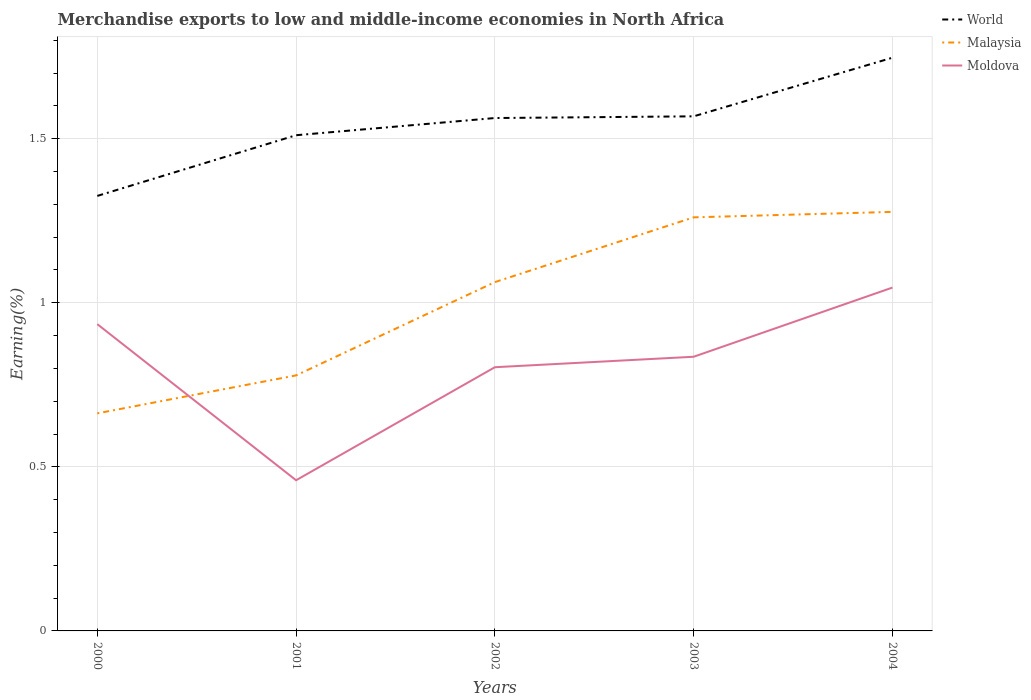Does the line corresponding to Moldova intersect with the line corresponding to Malaysia?
Provide a short and direct response. Yes. Is the number of lines equal to the number of legend labels?
Your response must be concise. Yes. Across all years, what is the maximum percentage of amount earned from merchandise exports in World?
Your answer should be compact. 1.33. What is the total percentage of amount earned from merchandise exports in World in the graph?
Offer a terse response. -0.18. What is the difference between the highest and the second highest percentage of amount earned from merchandise exports in Moldova?
Give a very brief answer. 0.59. Is the percentage of amount earned from merchandise exports in Malaysia strictly greater than the percentage of amount earned from merchandise exports in World over the years?
Make the answer very short. Yes. What is the difference between two consecutive major ticks on the Y-axis?
Make the answer very short. 0.5. How many legend labels are there?
Offer a very short reply. 3. What is the title of the graph?
Give a very brief answer. Merchandise exports to low and middle-income economies in North Africa. Does "Samoa" appear as one of the legend labels in the graph?
Your answer should be compact. No. What is the label or title of the X-axis?
Your answer should be very brief. Years. What is the label or title of the Y-axis?
Offer a very short reply. Earning(%). What is the Earning(%) in World in 2000?
Give a very brief answer. 1.33. What is the Earning(%) in Malaysia in 2000?
Give a very brief answer. 0.66. What is the Earning(%) of Moldova in 2000?
Your answer should be compact. 0.93. What is the Earning(%) in World in 2001?
Provide a short and direct response. 1.51. What is the Earning(%) in Malaysia in 2001?
Offer a very short reply. 0.78. What is the Earning(%) of Moldova in 2001?
Offer a terse response. 0.46. What is the Earning(%) of World in 2002?
Give a very brief answer. 1.56. What is the Earning(%) in Malaysia in 2002?
Ensure brevity in your answer.  1.06. What is the Earning(%) in Moldova in 2002?
Provide a succinct answer. 0.8. What is the Earning(%) of World in 2003?
Offer a very short reply. 1.57. What is the Earning(%) in Malaysia in 2003?
Offer a very short reply. 1.26. What is the Earning(%) of Moldova in 2003?
Provide a short and direct response. 0.84. What is the Earning(%) in World in 2004?
Your answer should be compact. 1.75. What is the Earning(%) of Malaysia in 2004?
Your response must be concise. 1.28. What is the Earning(%) of Moldova in 2004?
Keep it short and to the point. 1.05. Across all years, what is the maximum Earning(%) of World?
Ensure brevity in your answer.  1.75. Across all years, what is the maximum Earning(%) in Malaysia?
Offer a very short reply. 1.28. Across all years, what is the maximum Earning(%) in Moldova?
Provide a short and direct response. 1.05. Across all years, what is the minimum Earning(%) in World?
Your answer should be compact. 1.33. Across all years, what is the minimum Earning(%) of Malaysia?
Ensure brevity in your answer.  0.66. Across all years, what is the minimum Earning(%) in Moldova?
Your answer should be very brief. 0.46. What is the total Earning(%) of World in the graph?
Provide a succinct answer. 7.71. What is the total Earning(%) of Malaysia in the graph?
Offer a very short reply. 5.04. What is the total Earning(%) of Moldova in the graph?
Offer a very short reply. 4.08. What is the difference between the Earning(%) of World in 2000 and that in 2001?
Offer a terse response. -0.18. What is the difference between the Earning(%) of Malaysia in 2000 and that in 2001?
Your answer should be very brief. -0.12. What is the difference between the Earning(%) in Moldova in 2000 and that in 2001?
Keep it short and to the point. 0.48. What is the difference between the Earning(%) of World in 2000 and that in 2002?
Ensure brevity in your answer.  -0.24. What is the difference between the Earning(%) of Malaysia in 2000 and that in 2002?
Keep it short and to the point. -0.4. What is the difference between the Earning(%) of Moldova in 2000 and that in 2002?
Provide a succinct answer. 0.13. What is the difference between the Earning(%) of World in 2000 and that in 2003?
Offer a very short reply. -0.24. What is the difference between the Earning(%) in Malaysia in 2000 and that in 2003?
Keep it short and to the point. -0.6. What is the difference between the Earning(%) in Moldova in 2000 and that in 2003?
Provide a short and direct response. 0.1. What is the difference between the Earning(%) of World in 2000 and that in 2004?
Your response must be concise. -0.42. What is the difference between the Earning(%) in Malaysia in 2000 and that in 2004?
Your answer should be very brief. -0.61. What is the difference between the Earning(%) of Moldova in 2000 and that in 2004?
Your answer should be compact. -0.11. What is the difference between the Earning(%) in World in 2001 and that in 2002?
Keep it short and to the point. -0.05. What is the difference between the Earning(%) of Malaysia in 2001 and that in 2002?
Your answer should be compact. -0.28. What is the difference between the Earning(%) in Moldova in 2001 and that in 2002?
Offer a terse response. -0.34. What is the difference between the Earning(%) of World in 2001 and that in 2003?
Your answer should be compact. -0.06. What is the difference between the Earning(%) in Malaysia in 2001 and that in 2003?
Give a very brief answer. -0.48. What is the difference between the Earning(%) of Moldova in 2001 and that in 2003?
Provide a succinct answer. -0.38. What is the difference between the Earning(%) of World in 2001 and that in 2004?
Offer a terse response. -0.24. What is the difference between the Earning(%) of Malaysia in 2001 and that in 2004?
Your answer should be very brief. -0.5. What is the difference between the Earning(%) of Moldova in 2001 and that in 2004?
Give a very brief answer. -0.59. What is the difference between the Earning(%) in World in 2002 and that in 2003?
Provide a succinct answer. -0.01. What is the difference between the Earning(%) of Malaysia in 2002 and that in 2003?
Your response must be concise. -0.2. What is the difference between the Earning(%) in Moldova in 2002 and that in 2003?
Offer a terse response. -0.03. What is the difference between the Earning(%) in World in 2002 and that in 2004?
Ensure brevity in your answer.  -0.18. What is the difference between the Earning(%) in Malaysia in 2002 and that in 2004?
Give a very brief answer. -0.21. What is the difference between the Earning(%) in Moldova in 2002 and that in 2004?
Offer a very short reply. -0.24. What is the difference between the Earning(%) in World in 2003 and that in 2004?
Give a very brief answer. -0.18. What is the difference between the Earning(%) of Malaysia in 2003 and that in 2004?
Give a very brief answer. -0.02. What is the difference between the Earning(%) of Moldova in 2003 and that in 2004?
Offer a terse response. -0.21. What is the difference between the Earning(%) of World in 2000 and the Earning(%) of Malaysia in 2001?
Your response must be concise. 0.55. What is the difference between the Earning(%) in World in 2000 and the Earning(%) in Moldova in 2001?
Ensure brevity in your answer.  0.87. What is the difference between the Earning(%) in Malaysia in 2000 and the Earning(%) in Moldova in 2001?
Provide a short and direct response. 0.2. What is the difference between the Earning(%) in World in 2000 and the Earning(%) in Malaysia in 2002?
Your response must be concise. 0.26. What is the difference between the Earning(%) of World in 2000 and the Earning(%) of Moldova in 2002?
Keep it short and to the point. 0.52. What is the difference between the Earning(%) in Malaysia in 2000 and the Earning(%) in Moldova in 2002?
Your response must be concise. -0.14. What is the difference between the Earning(%) of World in 2000 and the Earning(%) of Malaysia in 2003?
Offer a very short reply. 0.07. What is the difference between the Earning(%) of World in 2000 and the Earning(%) of Moldova in 2003?
Provide a short and direct response. 0.49. What is the difference between the Earning(%) in Malaysia in 2000 and the Earning(%) in Moldova in 2003?
Provide a succinct answer. -0.17. What is the difference between the Earning(%) of World in 2000 and the Earning(%) of Malaysia in 2004?
Ensure brevity in your answer.  0.05. What is the difference between the Earning(%) of World in 2000 and the Earning(%) of Moldova in 2004?
Provide a short and direct response. 0.28. What is the difference between the Earning(%) in Malaysia in 2000 and the Earning(%) in Moldova in 2004?
Make the answer very short. -0.38. What is the difference between the Earning(%) of World in 2001 and the Earning(%) of Malaysia in 2002?
Keep it short and to the point. 0.45. What is the difference between the Earning(%) in World in 2001 and the Earning(%) in Moldova in 2002?
Make the answer very short. 0.71. What is the difference between the Earning(%) in Malaysia in 2001 and the Earning(%) in Moldova in 2002?
Provide a short and direct response. -0.02. What is the difference between the Earning(%) in World in 2001 and the Earning(%) in Malaysia in 2003?
Your answer should be compact. 0.25. What is the difference between the Earning(%) of World in 2001 and the Earning(%) of Moldova in 2003?
Give a very brief answer. 0.68. What is the difference between the Earning(%) of Malaysia in 2001 and the Earning(%) of Moldova in 2003?
Give a very brief answer. -0.06. What is the difference between the Earning(%) in World in 2001 and the Earning(%) in Malaysia in 2004?
Your answer should be compact. 0.23. What is the difference between the Earning(%) in World in 2001 and the Earning(%) in Moldova in 2004?
Give a very brief answer. 0.46. What is the difference between the Earning(%) of Malaysia in 2001 and the Earning(%) of Moldova in 2004?
Keep it short and to the point. -0.27. What is the difference between the Earning(%) of World in 2002 and the Earning(%) of Malaysia in 2003?
Ensure brevity in your answer.  0.3. What is the difference between the Earning(%) in World in 2002 and the Earning(%) in Moldova in 2003?
Keep it short and to the point. 0.73. What is the difference between the Earning(%) in Malaysia in 2002 and the Earning(%) in Moldova in 2003?
Your response must be concise. 0.23. What is the difference between the Earning(%) of World in 2002 and the Earning(%) of Malaysia in 2004?
Keep it short and to the point. 0.29. What is the difference between the Earning(%) of World in 2002 and the Earning(%) of Moldova in 2004?
Offer a terse response. 0.52. What is the difference between the Earning(%) of Malaysia in 2002 and the Earning(%) of Moldova in 2004?
Your response must be concise. 0.02. What is the difference between the Earning(%) in World in 2003 and the Earning(%) in Malaysia in 2004?
Provide a succinct answer. 0.29. What is the difference between the Earning(%) of World in 2003 and the Earning(%) of Moldova in 2004?
Your answer should be very brief. 0.52. What is the difference between the Earning(%) in Malaysia in 2003 and the Earning(%) in Moldova in 2004?
Your answer should be compact. 0.21. What is the average Earning(%) of World per year?
Provide a succinct answer. 1.54. What is the average Earning(%) in Malaysia per year?
Give a very brief answer. 1.01. What is the average Earning(%) in Moldova per year?
Your response must be concise. 0.82. In the year 2000, what is the difference between the Earning(%) of World and Earning(%) of Malaysia?
Your answer should be very brief. 0.66. In the year 2000, what is the difference between the Earning(%) of World and Earning(%) of Moldova?
Your answer should be compact. 0.39. In the year 2000, what is the difference between the Earning(%) in Malaysia and Earning(%) in Moldova?
Give a very brief answer. -0.27. In the year 2001, what is the difference between the Earning(%) in World and Earning(%) in Malaysia?
Offer a terse response. 0.73. In the year 2001, what is the difference between the Earning(%) of World and Earning(%) of Moldova?
Offer a very short reply. 1.05. In the year 2001, what is the difference between the Earning(%) in Malaysia and Earning(%) in Moldova?
Ensure brevity in your answer.  0.32. In the year 2002, what is the difference between the Earning(%) of World and Earning(%) of Malaysia?
Provide a succinct answer. 0.5. In the year 2002, what is the difference between the Earning(%) of World and Earning(%) of Moldova?
Offer a very short reply. 0.76. In the year 2002, what is the difference between the Earning(%) in Malaysia and Earning(%) in Moldova?
Offer a terse response. 0.26. In the year 2003, what is the difference between the Earning(%) in World and Earning(%) in Malaysia?
Give a very brief answer. 0.31. In the year 2003, what is the difference between the Earning(%) of World and Earning(%) of Moldova?
Offer a terse response. 0.73. In the year 2003, what is the difference between the Earning(%) of Malaysia and Earning(%) of Moldova?
Your response must be concise. 0.42. In the year 2004, what is the difference between the Earning(%) in World and Earning(%) in Malaysia?
Provide a short and direct response. 0.47. In the year 2004, what is the difference between the Earning(%) in World and Earning(%) in Moldova?
Provide a succinct answer. 0.7. In the year 2004, what is the difference between the Earning(%) in Malaysia and Earning(%) in Moldova?
Your answer should be compact. 0.23. What is the ratio of the Earning(%) of World in 2000 to that in 2001?
Keep it short and to the point. 0.88. What is the ratio of the Earning(%) in Malaysia in 2000 to that in 2001?
Provide a short and direct response. 0.85. What is the ratio of the Earning(%) of Moldova in 2000 to that in 2001?
Provide a succinct answer. 2.04. What is the ratio of the Earning(%) in World in 2000 to that in 2002?
Give a very brief answer. 0.85. What is the ratio of the Earning(%) of Malaysia in 2000 to that in 2002?
Keep it short and to the point. 0.62. What is the ratio of the Earning(%) of Moldova in 2000 to that in 2002?
Offer a terse response. 1.16. What is the ratio of the Earning(%) in World in 2000 to that in 2003?
Your answer should be very brief. 0.85. What is the ratio of the Earning(%) of Malaysia in 2000 to that in 2003?
Your answer should be very brief. 0.53. What is the ratio of the Earning(%) in Moldova in 2000 to that in 2003?
Ensure brevity in your answer.  1.12. What is the ratio of the Earning(%) in World in 2000 to that in 2004?
Provide a short and direct response. 0.76. What is the ratio of the Earning(%) of Malaysia in 2000 to that in 2004?
Your answer should be compact. 0.52. What is the ratio of the Earning(%) in Moldova in 2000 to that in 2004?
Offer a very short reply. 0.89. What is the ratio of the Earning(%) in World in 2001 to that in 2002?
Your response must be concise. 0.97. What is the ratio of the Earning(%) of Malaysia in 2001 to that in 2002?
Give a very brief answer. 0.73. What is the ratio of the Earning(%) of Moldova in 2001 to that in 2002?
Ensure brevity in your answer.  0.57. What is the ratio of the Earning(%) in World in 2001 to that in 2003?
Offer a terse response. 0.96. What is the ratio of the Earning(%) in Malaysia in 2001 to that in 2003?
Offer a very short reply. 0.62. What is the ratio of the Earning(%) of Moldova in 2001 to that in 2003?
Your answer should be compact. 0.55. What is the ratio of the Earning(%) of World in 2001 to that in 2004?
Make the answer very short. 0.86. What is the ratio of the Earning(%) of Malaysia in 2001 to that in 2004?
Your response must be concise. 0.61. What is the ratio of the Earning(%) in Moldova in 2001 to that in 2004?
Offer a terse response. 0.44. What is the ratio of the Earning(%) in Malaysia in 2002 to that in 2003?
Offer a very short reply. 0.84. What is the ratio of the Earning(%) in Moldova in 2002 to that in 2003?
Offer a terse response. 0.96. What is the ratio of the Earning(%) in World in 2002 to that in 2004?
Ensure brevity in your answer.  0.89. What is the ratio of the Earning(%) of Malaysia in 2002 to that in 2004?
Make the answer very short. 0.83. What is the ratio of the Earning(%) in Moldova in 2002 to that in 2004?
Provide a succinct answer. 0.77. What is the ratio of the Earning(%) of World in 2003 to that in 2004?
Keep it short and to the point. 0.9. What is the ratio of the Earning(%) in Malaysia in 2003 to that in 2004?
Your response must be concise. 0.99. What is the ratio of the Earning(%) of Moldova in 2003 to that in 2004?
Provide a succinct answer. 0.8. What is the difference between the highest and the second highest Earning(%) in World?
Provide a short and direct response. 0.18. What is the difference between the highest and the second highest Earning(%) in Malaysia?
Give a very brief answer. 0.02. What is the difference between the highest and the second highest Earning(%) of Moldova?
Provide a succinct answer. 0.11. What is the difference between the highest and the lowest Earning(%) of World?
Offer a very short reply. 0.42. What is the difference between the highest and the lowest Earning(%) in Malaysia?
Make the answer very short. 0.61. What is the difference between the highest and the lowest Earning(%) of Moldova?
Give a very brief answer. 0.59. 